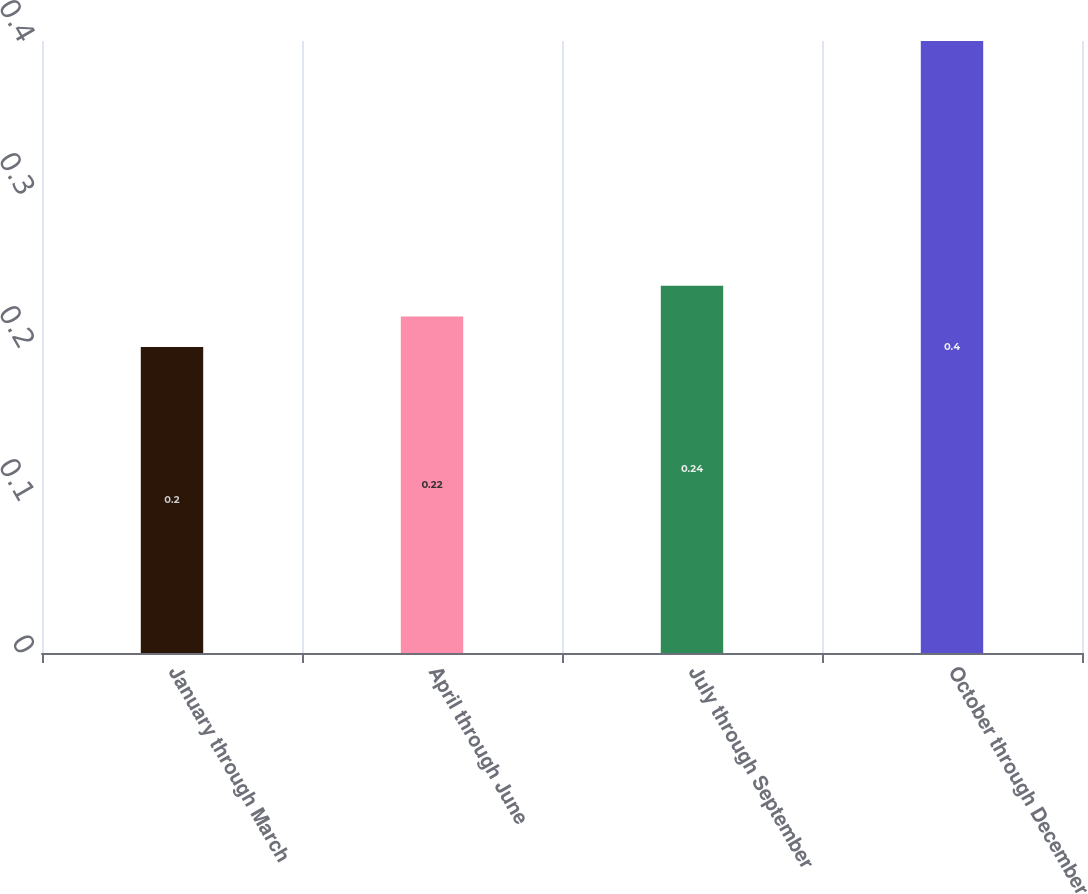Convert chart. <chart><loc_0><loc_0><loc_500><loc_500><bar_chart><fcel>January through March<fcel>April through June<fcel>July through September<fcel>October through December<nl><fcel>0.2<fcel>0.22<fcel>0.24<fcel>0.4<nl></chart> 